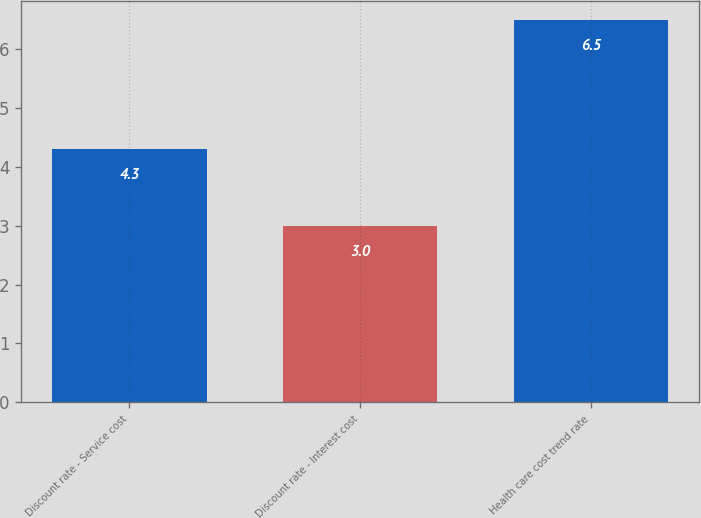Convert chart to OTSL. <chart><loc_0><loc_0><loc_500><loc_500><bar_chart><fcel>Discount rate - Service cost<fcel>Discount rate - Interest cost<fcel>Health care cost trend rate<nl><fcel>4.3<fcel>3<fcel>6.5<nl></chart> 